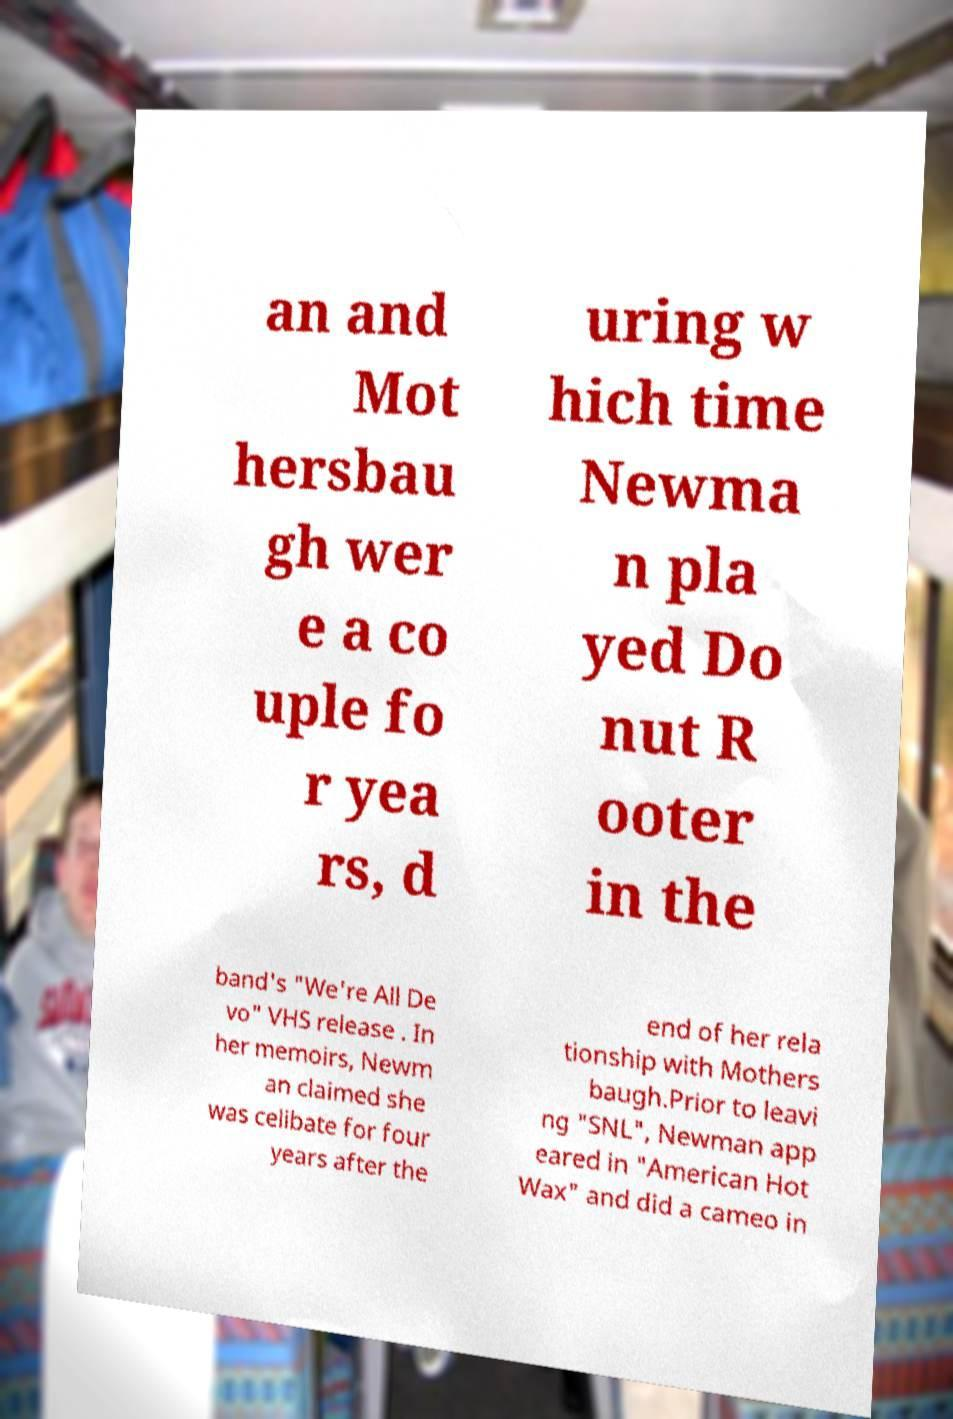Please read and relay the text visible in this image. What does it say? an and Mot hersbau gh wer e a co uple fo r yea rs, d uring w hich time Newma n pla yed Do nut R ooter in the band's "We're All De vo" VHS release . In her memoirs, Newm an claimed she was celibate for four years after the end of her rela tionship with Mothers baugh.Prior to leavi ng "SNL", Newman app eared in "American Hot Wax" and did a cameo in 